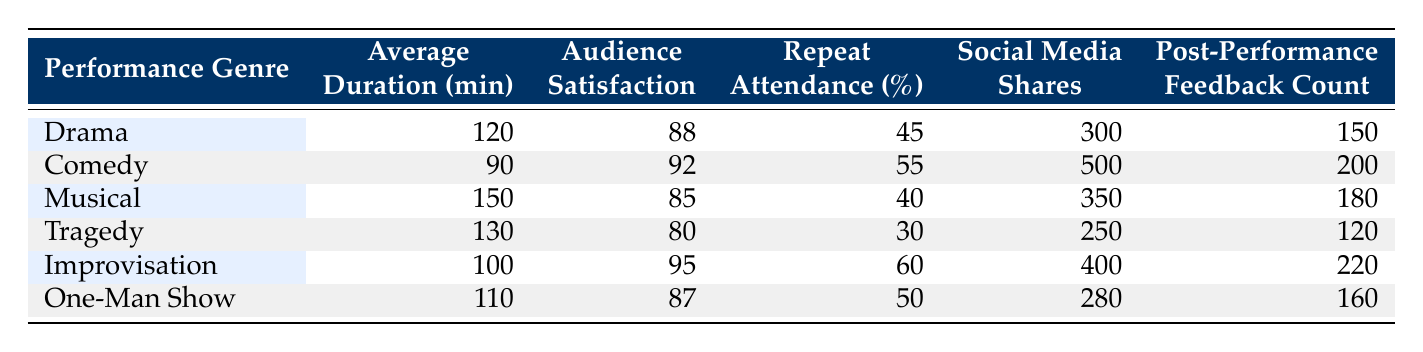What is the average duration of the Comedy performance genre? The table shows the Average Duration for Comedy as 90 minutes.
Answer: 90 minutes Which performance genre has the highest Audience Satisfaction Score? By comparing the Audience Satisfaction Scores for each genre, Comedy has the highest score at 92.
Answer: Comedy Is the Repeat Attendance Rate for Tragedy higher than that of Musical? The Repeat Attendance Rate for Tragedy is 30%, and for Musical, it is 40%. Since 30 is less than 40, the statement is false.
Answer: No What is the total number of Post-Performance Feedback Counts for both Improvisation and Musical? The Post-Performance Feedback Count for Improvisation is 220, and for Musical, it is 180. Adding these gives 220 + 180 = 400.
Answer: 400 Which performance genre has the lowest Social Media Shares? Checking the Social Media Shares across genres reveals that Tragedy has the lowest at 250 shares.
Answer: Tragedy What is the median Average Duration among all performance genres? Arranging the Average Durations in ascending order gives: 90 (Comedy), 100 (Improvisation), 110 (One-Man Show), 120 (Drama), 130 (Tragedy), 150 (Musical). There are six values, so the median is the average of the 3rd (110) and 4th (120) values: (110 + 120) / 2 = 115.
Answer: 115 Do Improvisation and Comedy both have an Audience Satisfaction Score above 90? Checking the scores, Improvisation has 95 and Comedy has 92. Both are above 90, confirming the statement is true.
Answer: Yes What is the difference in Social Media Shares between Comedy and One-Man Show? The Social Media Shares for Comedy is 500 and for One-Man Show is 280. The difference is 500 - 280 = 220.
Answer: 220 